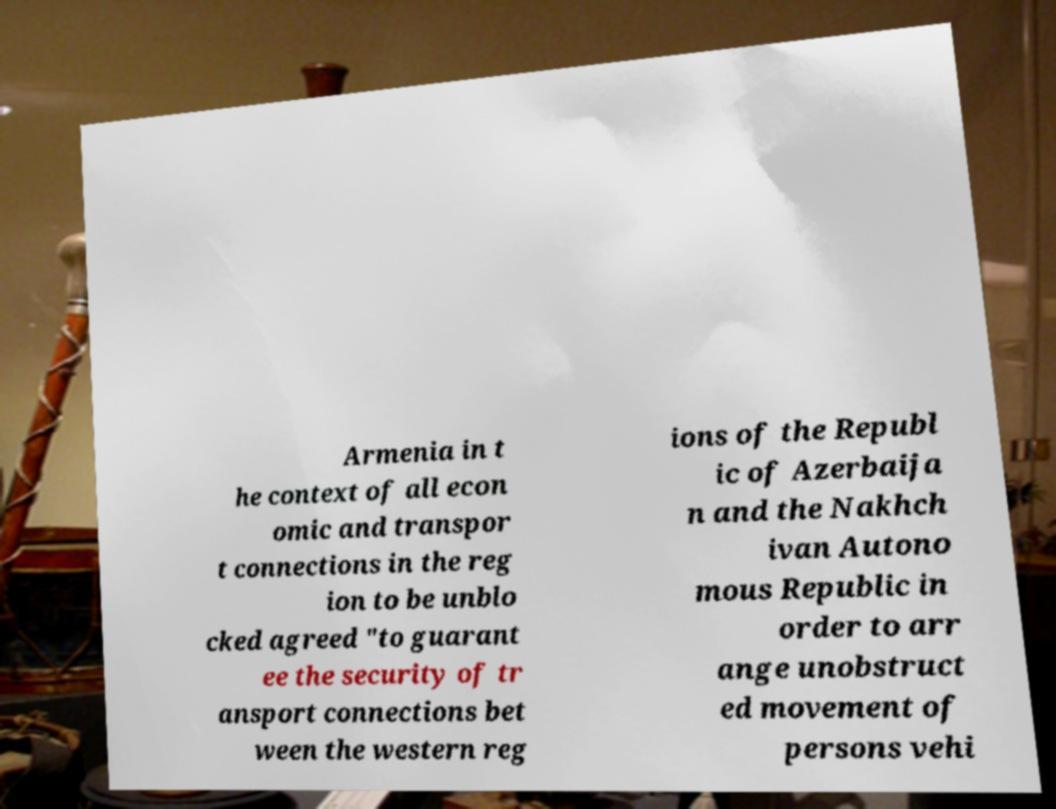Could you assist in decoding the text presented in this image and type it out clearly? Armenia in t he context of all econ omic and transpor t connections in the reg ion to be unblo cked agreed "to guarant ee the security of tr ansport connections bet ween the western reg ions of the Republ ic of Azerbaija n and the Nakhch ivan Autono mous Republic in order to arr ange unobstruct ed movement of persons vehi 